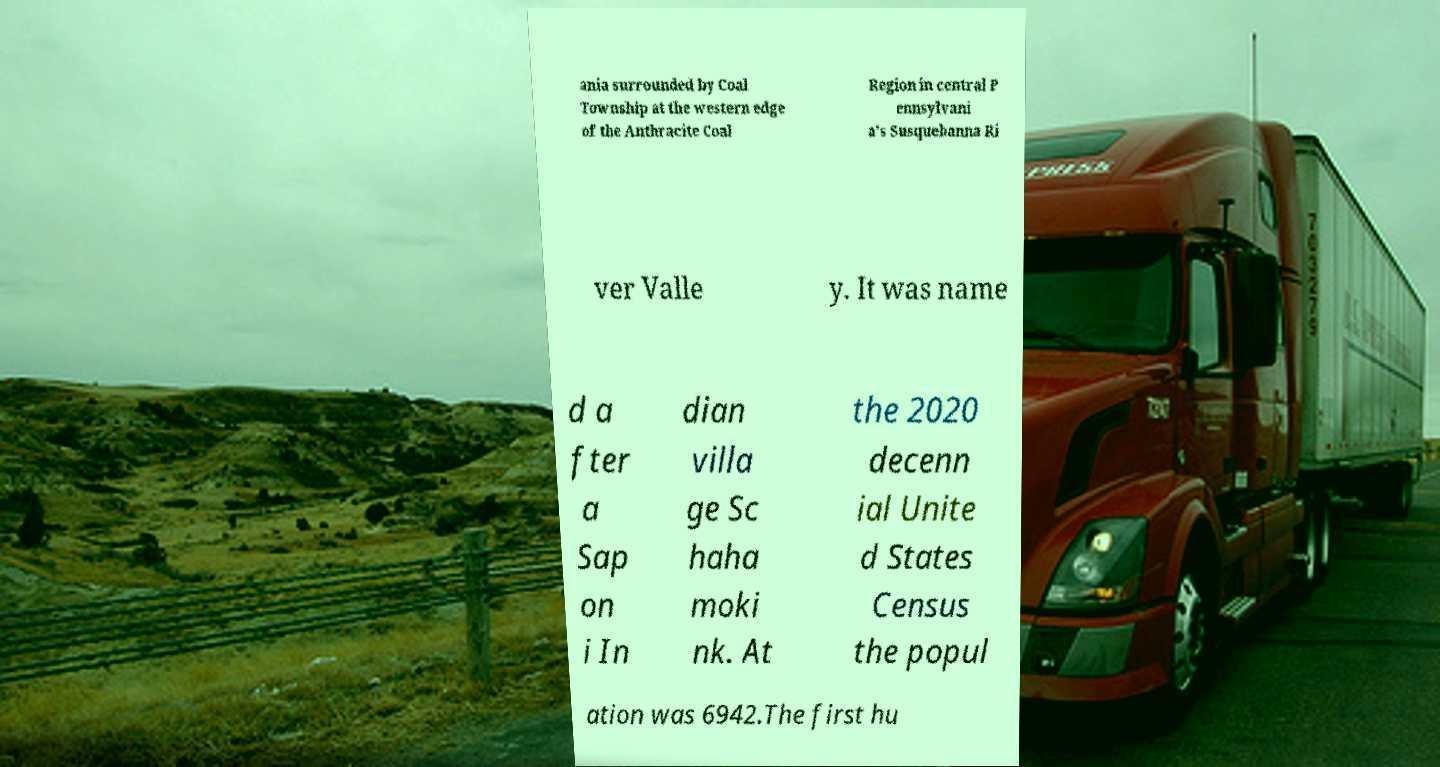Can you read and provide the text displayed in the image?This photo seems to have some interesting text. Can you extract and type it out for me? ania surrounded by Coal Township at the western edge of the Anthracite Coal Region in central P ennsylvani a's Susquehanna Ri ver Valle y. It was name d a fter a Sap on i In dian villa ge Sc haha moki nk. At the 2020 decenn ial Unite d States Census the popul ation was 6942.The first hu 